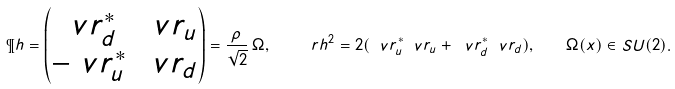<formula> <loc_0><loc_0><loc_500><loc_500>\P h = \begin{pmatrix} \ v r _ { d } ^ { * } & \ v r _ { u } \\ - \ v r _ { u } ^ { * } & \ v r _ { d } \end{pmatrix} = \frac { \rho } { \sqrt { 2 } } \, \Omega , \quad \ r h ^ { 2 } = 2 ( \ v r _ { u } ^ { * } \ v r _ { u } + \ v r _ { d } ^ { * } \ v r _ { d } ) , \quad \Omega ( x ) \in S U ( 2 ) .</formula> 